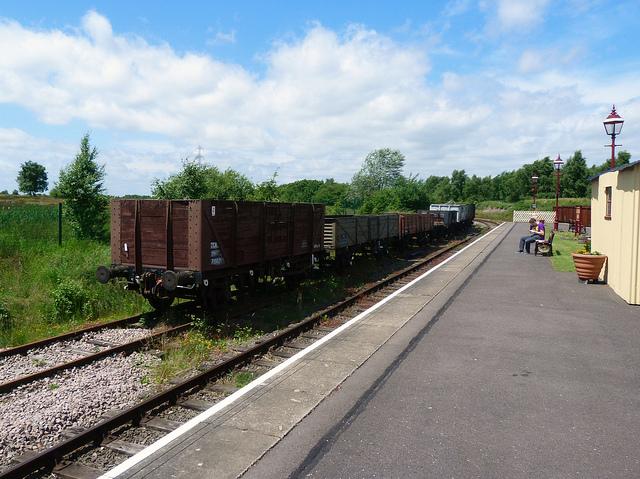What is the yellow building for?
Concise answer only. Train station. How many train cars do you see?
Write a very short answer. 5. How many people are waiting for a train?
Concise answer only. 2. Is the train coming or going?
Keep it brief. Going. How many people can be seen?
Answer briefly. 2. Is it a sunny day?
Short answer required. Yes. 